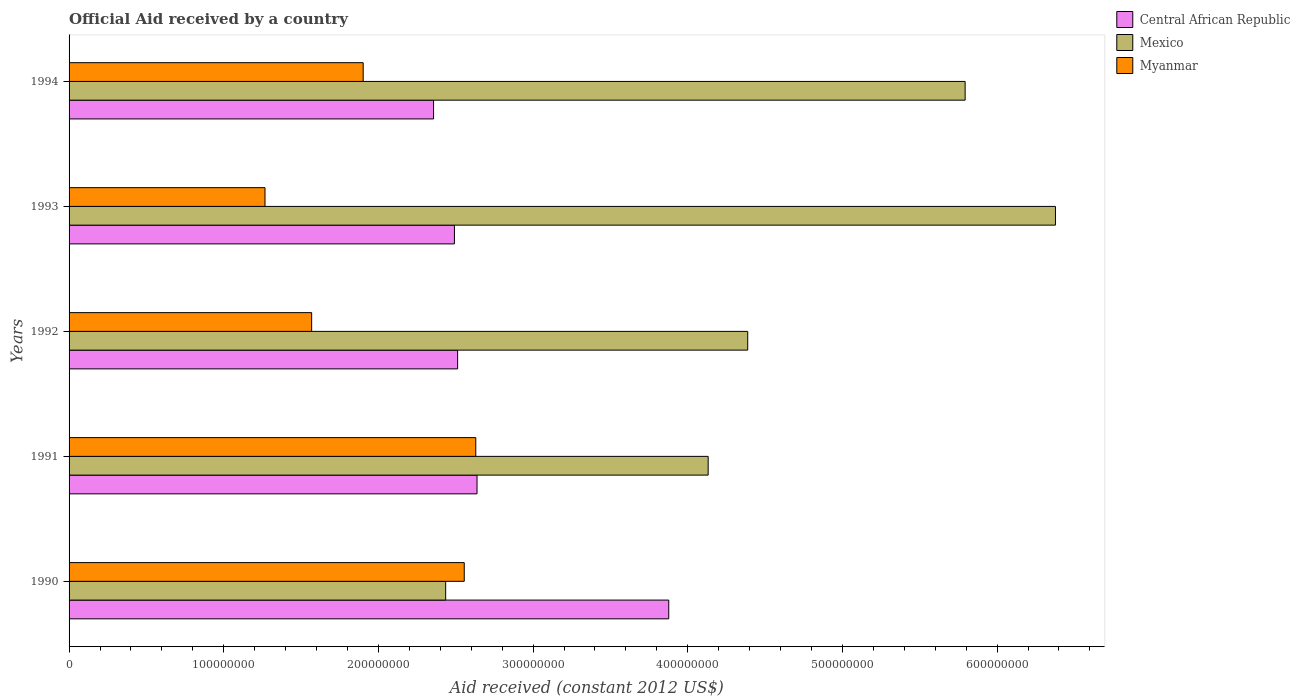How many different coloured bars are there?
Your answer should be compact. 3. Are the number of bars per tick equal to the number of legend labels?
Your answer should be very brief. Yes. Are the number of bars on each tick of the Y-axis equal?
Offer a terse response. Yes. What is the net official aid received in Mexico in 1990?
Ensure brevity in your answer.  2.43e+08. Across all years, what is the maximum net official aid received in Myanmar?
Offer a very short reply. 2.63e+08. Across all years, what is the minimum net official aid received in Mexico?
Ensure brevity in your answer.  2.43e+08. In which year was the net official aid received in Central African Republic maximum?
Provide a short and direct response. 1990. What is the total net official aid received in Central African Republic in the graph?
Make the answer very short. 1.39e+09. What is the difference between the net official aid received in Mexico in 1993 and that in 1994?
Make the answer very short. 5.84e+07. What is the difference between the net official aid received in Myanmar in 1990 and the net official aid received in Central African Republic in 1994?
Your answer should be compact. 1.98e+07. What is the average net official aid received in Mexico per year?
Offer a very short reply. 4.62e+08. In the year 1990, what is the difference between the net official aid received in Central African Republic and net official aid received in Myanmar?
Your answer should be very brief. 1.32e+08. What is the ratio of the net official aid received in Mexico in 1990 to that in 1994?
Give a very brief answer. 0.42. Is the net official aid received in Mexico in 1991 less than that in 1994?
Your answer should be very brief. Yes. What is the difference between the highest and the second highest net official aid received in Myanmar?
Ensure brevity in your answer.  7.46e+06. What is the difference between the highest and the lowest net official aid received in Central African Republic?
Your response must be concise. 1.52e+08. In how many years, is the net official aid received in Mexico greater than the average net official aid received in Mexico taken over all years?
Ensure brevity in your answer.  2. What does the 2nd bar from the top in 1990 represents?
Ensure brevity in your answer.  Mexico. What does the 3rd bar from the bottom in 1994 represents?
Your answer should be compact. Myanmar. Are all the bars in the graph horizontal?
Offer a very short reply. Yes. How many legend labels are there?
Make the answer very short. 3. What is the title of the graph?
Keep it short and to the point. Official Aid received by a country. What is the label or title of the X-axis?
Provide a short and direct response. Aid received (constant 2012 US$). What is the Aid received (constant 2012 US$) in Central African Republic in 1990?
Your answer should be compact. 3.88e+08. What is the Aid received (constant 2012 US$) in Mexico in 1990?
Your response must be concise. 2.43e+08. What is the Aid received (constant 2012 US$) in Myanmar in 1990?
Provide a short and direct response. 2.55e+08. What is the Aid received (constant 2012 US$) of Central African Republic in 1991?
Offer a very short reply. 2.64e+08. What is the Aid received (constant 2012 US$) of Mexico in 1991?
Your answer should be very brief. 4.13e+08. What is the Aid received (constant 2012 US$) of Myanmar in 1991?
Make the answer very short. 2.63e+08. What is the Aid received (constant 2012 US$) in Central African Republic in 1992?
Ensure brevity in your answer.  2.51e+08. What is the Aid received (constant 2012 US$) in Mexico in 1992?
Your answer should be very brief. 4.39e+08. What is the Aid received (constant 2012 US$) in Myanmar in 1992?
Give a very brief answer. 1.57e+08. What is the Aid received (constant 2012 US$) in Central African Republic in 1993?
Your answer should be compact. 2.49e+08. What is the Aid received (constant 2012 US$) of Mexico in 1993?
Your response must be concise. 6.38e+08. What is the Aid received (constant 2012 US$) of Myanmar in 1993?
Your answer should be compact. 1.27e+08. What is the Aid received (constant 2012 US$) of Central African Republic in 1994?
Provide a succinct answer. 2.36e+08. What is the Aid received (constant 2012 US$) in Mexico in 1994?
Offer a terse response. 5.79e+08. What is the Aid received (constant 2012 US$) of Myanmar in 1994?
Provide a short and direct response. 1.90e+08. Across all years, what is the maximum Aid received (constant 2012 US$) of Central African Republic?
Make the answer very short. 3.88e+08. Across all years, what is the maximum Aid received (constant 2012 US$) in Mexico?
Offer a very short reply. 6.38e+08. Across all years, what is the maximum Aid received (constant 2012 US$) of Myanmar?
Ensure brevity in your answer.  2.63e+08. Across all years, what is the minimum Aid received (constant 2012 US$) of Central African Republic?
Provide a short and direct response. 2.36e+08. Across all years, what is the minimum Aid received (constant 2012 US$) of Mexico?
Provide a short and direct response. 2.43e+08. Across all years, what is the minimum Aid received (constant 2012 US$) of Myanmar?
Provide a short and direct response. 1.27e+08. What is the total Aid received (constant 2012 US$) of Central African Republic in the graph?
Give a very brief answer. 1.39e+09. What is the total Aid received (constant 2012 US$) in Mexico in the graph?
Keep it short and to the point. 2.31e+09. What is the total Aid received (constant 2012 US$) of Myanmar in the graph?
Offer a very short reply. 9.92e+08. What is the difference between the Aid received (constant 2012 US$) in Central African Republic in 1990 and that in 1991?
Offer a terse response. 1.24e+08. What is the difference between the Aid received (constant 2012 US$) in Mexico in 1990 and that in 1991?
Your response must be concise. -1.70e+08. What is the difference between the Aid received (constant 2012 US$) in Myanmar in 1990 and that in 1991?
Provide a succinct answer. -7.46e+06. What is the difference between the Aid received (constant 2012 US$) of Central African Republic in 1990 and that in 1992?
Make the answer very short. 1.36e+08. What is the difference between the Aid received (constant 2012 US$) of Mexico in 1990 and that in 1992?
Your answer should be very brief. -1.95e+08. What is the difference between the Aid received (constant 2012 US$) in Myanmar in 1990 and that in 1992?
Provide a succinct answer. 9.86e+07. What is the difference between the Aid received (constant 2012 US$) in Central African Republic in 1990 and that in 1993?
Your response must be concise. 1.39e+08. What is the difference between the Aid received (constant 2012 US$) of Mexico in 1990 and that in 1993?
Give a very brief answer. -3.94e+08. What is the difference between the Aid received (constant 2012 US$) of Myanmar in 1990 and that in 1993?
Your response must be concise. 1.29e+08. What is the difference between the Aid received (constant 2012 US$) in Central African Republic in 1990 and that in 1994?
Offer a terse response. 1.52e+08. What is the difference between the Aid received (constant 2012 US$) of Mexico in 1990 and that in 1994?
Offer a terse response. -3.36e+08. What is the difference between the Aid received (constant 2012 US$) in Myanmar in 1990 and that in 1994?
Provide a short and direct response. 6.54e+07. What is the difference between the Aid received (constant 2012 US$) in Central African Republic in 1991 and that in 1992?
Provide a short and direct response. 1.26e+07. What is the difference between the Aid received (constant 2012 US$) of Mexico in 1991 and that in 1992?
Your answer should be compact. -2.56e+07. What is the difference between the Aid received (constant 2012 US$) of Myanmar in 1991 and that in 1992?
Keep it short and to the point. 1.06e+08. What is the difference between the Aid received (constant 2012 US$) of Central African Republic in 1991 and that in 1993?
Your response must be concise. 1.46e+07. What is the difference between the Aid received (constant 2012 US$) of Mexico in 1991 and that in 1993?
Give a very brief answer. -2.25e+08. What is the difference between the Aid received (constant 2012 US$) of Myanmar in 1991 and that in 1993?
Ensure brevity in your answer.  1.36e+08. What is the difference between the Aid received (constant 2012 US$) of Central African Republic in 1991 and that in 1994?
Make the answer very short. 2.81e+07. What is the difference between the Aid received (constant 2012 US$) in Mexico in 1991 and that in 1994?
Ensure brevity in your answer.  -1.66e+08. What is the difference between the Aid received (constant 2012 US$) in Myanmar in 1991 and that in 1994?
Provide a short and direct response. 7.28e+07. What is the difference between the Aid received (constant 2012 US$) of Central African Republic in 1992 and that in 1993?
Give a very brief answer. 2.06e+06. What is the difference between the Aid received (constant 2012 US$) of Mexico in 1992 and that in 1993?
Offer a terse response. -1.99e+08. What is the difference between the Aid received (constant 2012 US$) of Myanmar in 1992 and that in 1993?
Make the answer very short. 3.02e+07. What is the difference between the Aid received (constant 2012 US$) of Central African Republic in 1992 and that in 1994?
Provide a short and direct response. 1.56e+07. What is the difference between the Aid received (constant 2012 US$) in Mexico in 1992 and that in 1994?
Give a very brief answer. -1.41e+08. What is the difference between the Aid received (constant 2012 US$) in Myanmar in 1992 and that in 1994?
Ensure brevity in your answer.  -3.33e+07. What is the difference between the Aid received (constant 2012 US$) in Central African Republic in 1993 and that in 1994?
Give a very brief answer. 1.35e+07. What is the difference between the Aid received (constant 2012 US$) in Mexico in 1993 and that in 1994?
Your response must be concise. 5.84e+07. What is the difference between the Aid received (constant 2012 US$) in Myanmar in 1993 and that in 1994?
Provide a succinct answer. -6.35e+07. What is the difference between the Aid received (constant 2012 US$) of Central African Republic in 1990 and the Aid received (constant 2012 US$) of Mexico in 1991?
Your response must be concise. -2.55e+07. What is the difference between the Aid received (constant 2012 US$) in Central African Republic in 1990 and the Aid received (constant 2012 US$) in Myanmar in 1991?
Ensure brevity in your answer.  1.25e+08. What is the difference between the Aid received (constant 2012 US$) in Mexico in 1990 and the Aid received (constant 2012 US$) in Myanmar in 1991?
Make the answer very short. -1.95e+07. What is the difference between the Aid received (constant 2012 US$) of Central African Republic in 1990 and the Aid received (constant 2012 US$) of Mexico in 1992?
Offer a very short reply. -5.10e+07. What is the difference between the Aid received (constant 2012 US$) in Central African Republic in 1990 and the Aid received (constant 2012 US$) in Myanmar in 1992?
Ensure brevity in your answer.  2.31e+08. What is the difference between the Aid received (constant 2012 US$) of Mexico in 1990 and the Aid received (constant 2012 US$) of Myanmar in 1992?
Ensure brevity in your answer.  8.66e+07. What is the difference between the Aid received (constant 2012 US$) in Central African Republic in 1990 and the Aid received (constant 2012 US$) in Mexico in 1993?
Offer a terse response. -2.50e+08. What is the difference between the Aid received (constant 2012 US$) of Central African Republic in 1990 and the Aid received (constant 2012 US$) of Myanmar in 1993?
Give a very brief answer. 2.61e+08. What is the difference between the Aid received (constant 2012 US$) of Mexico in 1990 and the Aid received (constant 2012 US$) of Myanmar in 1993?
Your answer should be compact. 1.17e+08. What is the difference between the Aid received (constant 2012 US$) in Central African Republic in 1990 and the Aid received (constant 2012 US$) in Mexico in 1994?
Make the answer very short. -1.92e+08. What is the difference between the Aid received (constant 2012 US$) of Central African Republic in 1990 and the Aid received (constant 2012 US$) of Myanmar in 1994?
Make the answer very short. 1.98e+08. What is the difference between the Aid received (constant 2012 US$) of Mexico in 1990 and the Aid received (constant 2012 US$) of Myanmar in 1994?
Ensure brevity in your answer.  5.33e+07. What is the difference between the Aid received (constant 2012 US$) of Central African Republic in 1991 and the Aid received (constant 2012 US$) of Mexico in 1992?
Your answer should be very brief. -1.75e+08. What is the difference between the Aid received (constant 2012 US$) in Central African Republic in 1991 and the Aid received (constant 2012 US$) in Myanmar in 1992?
Your answer should be very brief. 1.07e+08. What is the difference between the Aid received (constant 2012 US$) of Mexico in 1991 and the Aid received (constant 2012 US$) of Myanmar in 1992?
Provide a short and direct response. 2.56e+08. What is the difference between the Aid received (constant 2012 US$) of Central African Republic in 1991 and the Aid received (constant 2012 US$) of Mexico in 1993?
Keep it short and to the point. -3.74e+08. What is the difference between the Aid received (constant 2012 US$) of Central African Republic in 1991 and the Aid received (constant 2012 US$) of Myanmar in 1993?
Make the answer very short. 1.37e+08. What is the difference between the Aid received (constant 2012 US$) of Mexico in 1991 and the Aid received (constant 2012 US$) of Myanmar in 1993?
Your answer should be compact. 2.87e+08. What is the difference between the Aid received (constant 2012 US$) in Central African Republic in 1991 and the Aid received (constant 2012 US$) in Mexico in 1994?
Provide a short and direct response. -3.16e+08. What is the difference between the Aid received (constant 2012 US$) of Central African Republic in 1991 and the Aid received (constant 2012 US$) of Myanmar in 1994?
Offer a very short reply. 7.36e+07. What is the difference between the Aid received (constant 2012 US$) of Mexico in 1991 and the Aid received (constant 2012 US$) of Myanmar in 1994?
Your answer should be compact. 2.23e+08. What is the difference between the Aid received (constant 2012 US$) in Central African Republic in 1992 and the Aid received (constant 2012 US$) in Mexico in 1993?
Ensure brevity in your answer.  -3.87e+08. What is the difference between the Aid received (constant 2012 US$) of Central African Republic in 1992 and the Aid received (constant 2012 US$) of Myanmar in 1993?
Ensure brevity in your answer.  1.25e+08. What is the difference between the Aid received (constant 2012 US$) of Mexico in 1992 and the Aid received (constant 2012 US$) of Myanmar in 1993?
Offer a very short reply. 3.12e+08. What is the difference between the Aid received (constant 2012 US$) of Central African Republic in 1992 and the Aid received (constant 2012 US$) of Mexico in 1994?
Your answer should be very brief. -3.28e+08. What is the difference between the Aid received (constant 2012 US$) in Central African Republic in 1992 and the Aid received (constant 2012 US$) in Myanmar in 1994?
Keep it short and to the point. 6.11e+07. What is the difference between the Aid received (constant 2012 US$) of Mexico in 1992 and the Aid received (constant 2012 US$) of Myanmar in 1994?
Give a very brief answer. 2.49e+08. What is the difference between the Aid received (constant 2012 US$) in Central African Republic in 1993 and the Aid received (constant 2012 US$) in Mexico in 1994?
Make the answer very short. -3.30e+08. What is the difference between the Aid received (constant 2012 US$) of Central African Republic in 1993 and the Aid received (constant 2012 US$) of Myanmar in 1994?
Offer a terse response. 5.90e+07. What is the difference between the Aid received (constant 2012 US$) in Mexico in 1993 and the Aid received (constant 2012 US$) in Myanmar in 1994?
Offer a terse response. 4.48e+08. What is the average Aid received (constant 2012 US$) of Central African Republic per year?
Your response must be concise. 2.77e+08. What is the average Aid received (constant 2012 US$) in Mexico per year?
Your response must be concise. 4.62e+08. What is the average Aid received (constant 2012 US$) of Myanmar per year?
Make the answer very short. 1.98e+08. In the year 1990, what is the difference between the Aid received (constant 2012 US$) in Central African Republic and Aid received (constant 2012 US$) in Mexico?
Give a very brief answer. 1.44e+08. In the year 1990, what is the difference between the Aid received (constant 2012 US$) in Central African Republic and Aid received (constant 2012 US$) in Myanmar?
Your answer should be compact. 1.32e+08. In the year 1990, what is the difference between the Aid received (constant 2012 US$) in Mexico and Aid received (constant 2012 US$) in Myanmar?
Your answer should be very brief. -1.20e+07. In the year 1991, what is the difference between the Aid received (constant 2012 US$) in Central African Republic and Aid received (constant 2012 US$) in Mexico?
Provide a succinct answer. -1.49e+08. In the year 1991, what is the difference between the Aid received (constant 2012 US$) in Central African Republic and Aid received (constant 2012 US$) in Myanmar?
Make the answer very short. 8.10e+05. In the year 1991, what is the difference between the Aid received (constant 2012 US$) in Mexico and Aid received (constant 2012 US$) in Myanmar?
Provide a succinct answer. 1.50e+08. In the year 1992, what is the difference between the Aid received (constant 2012 US$) of Central African Republic and Aid received (constant 2012 US$) of Mexico?
Give a very brief answer. -1.88e+08. In the year 1992, what is the difference between the Aid received (constant 2012 US$) of Central African Republic and Aid received (constant 2012 US$) of Myanmar?
Offer a terse response. 9.44e+07. In the year 1992, what is the difference between the Aid received (constant 2012 US$) in Mexico and Aid received (constant 2012 US$) in Myanmar?
Offer a terse response. 2.82e+08. In the year 1993, what is the difference between the Aid received (constant 2012 US$) in Central African Republic and Aid received (constant 2012 US$) in Mexico?
Make the answer very short. -3.89e+08. In the year 1993, what is the difference between the Aid received (constant 2012 US$) of Central African Republic and Aid received (constant 2012 US$) of Myanmar?
Ensure brevity in your answer.  1.22e+08. In the year 1993, what is the difference between the Aid received (constant 2012 US$) in Mexico and Aid received (constant 2012 US$) in Myanmar?
Offer a terse response. 5.11e+08. In the year 1994, what is the difference between the Aid received (constant 2012 US$) in Central African Republic and Aid received (constant 2012 US$) in Mexico?
Provide a short and direct response. -3.44e+08. In the year 1994, what is the difference between the Aid received (constant 2012 US$) of Central African Republic and Aid received (constant 2012 US$) of Myanmar?
Make the answer very short. 4.55e+07. In the year 1994, what is the difference between the Aid received (constant 2012 US$) of Mexico and Aid received (constant 2012 US$) of Myanmar?
Provide a short and direct response. 3.89e+08. What is the ratio of the Aid received (constant 2012 US$) of Central African Republic in 1990 to that in 1991?
Ensure brevity in your answer.  1.47. What is the ratio of the Aid received (constant 2012 US$) in Mexico in 1990 to that in 1991?
Offer a terse response. 0.59. What is the ratio of the Aid received (constant 2012 US$) in Myanmar in 1990 to that in 1991?
Provide a short and direct response. 0.97. What is the ratio of the Aid received (constant 2012 US$) in Central African Republic in 1990 to that in 1992?
Offer a terse response. 1.54. What is the ratio of the Aid received (constant 2012 US$) in Mexico in 1990 to that in 1992?
Keep it short and to the point. 0.55. What is the ratio of the Aid received (constant 2012 US$) in Myanmar in 1990 to that in 1992?
Make the answer very short. 1.63. What is the ratio of the Aid received (constant 2012 US$) in Central African Republic in 1990 to that in 1993?
Your answer should be very brief. 1.56. What is the ratio of the Aid received (constant 2012 US$) in Mexico in 1990 to that in 1993?
Your answer should be compact. 0.38. What is the ratio of the Aid received (constant 2012 US$) in Myanmar in 1990 to that in 1993?
Offer a very short reply. 2.02. What is the ratio of the Aid received (constant 2012 US$) in Central African Republic in 1990 to that in 1994?
Ensure brevity in your answer.  1.65. What is the ratio of the Aid received (constant 2012 US$) in Mexico in 1990 to that in 1994?
Your response must be concise. 0.42. What is the ratio of the Aid received (constant 2012 US$) in Myanmar in 1990 to that in 1994?
Give a very brief answer. 1.34. What is the ratio of the Aid received (constant 2012 US$) of Mexico in 1991 to that in 1992?
Keep it short and to the point. 0.94. What is the ratio of the Aid received (constant 2012 US$) in Myanmar in 1991 to that in 1992?
Give a very brief answer. 1.68. What is the ratio of the Aid received (constant 2012 US$) of Central African Republic in 1991 to that in 1993?
Your answer should be compact. 1.06. What is the ratio of the Aid received (constant 2012 US$) of Mexico in 1991 to that in 1993?
Keep it short and to the point. 0.65. What is the ratio of the Aid received (constant 2012 US$) in Myanmar in 1991 to that in 1993?
Give a very brief answer. 2.08. What is the ratio of the Aid received (constant 2012 US$) in Central African Republic in 1991 to that in 1994?
Keep it short and to the point. 1.12. What is the ratio of the Aid received (constant 2012 US$) of Mexico in 1991 to that in 1994?
Ensure brevity in your answer.  0.71. What is the ratio of the Aid received (constant 2012 US$) in Myanmar in 1991 to that in 1994?
Keep it short and to the point. 1.38. What is the ratio of the Aid received (constant 2012 US$) of Central African Republic in 1992 to that in 1993?
Provide a succinct answer. 1.01. What is the ratio of the Aid received (constant 2012 US$) of Mexico in 1992 to that in 1993?
Your response must be concise. 0.69. What is the ratio of the Aid received (constant 2012 US$) of Myanmar in 1992 to that in 1993?
Provide a succinct answer. 1.24. What is the ratio of the Aid received (constant 2012 US$) in Central African Republic in 1992 to that in 1994?
Your answer should be compact. 1.07. What is the ratio of the Aid received (constant 2012 US$) of Mexico in 1992 to that in 1994?
Your answer should be compact. 0.76. What is the ratio of the Aid received (constant 2012 US$) in Myanmar in 1992 to that in 1994?
Offer a terse response. 0.82. What is the ratio of the Aid received (constant 2012 US$) of Central African Republic in 1993 to that in 1994?
Make the answer very short. 1.06. What is the ratio of the Aid received (constant 2012 US$) in Mexico in 1993 to that in 1994?
Provide a short and direct response. 1.1. What is the ratio of the Aid received (constant 2012 US$) of Myanmar in 1993 to that in 1994?
Your answer should be compact. 0.67. What is the difference between the highest and the second highest Aid received (constant 2012 US$) in Central African Republic?
Your answer should be compact. 1.24e+08. What is the difference between the highest and the second highest Aid received (constant 2012 US$) in Mexico?
Give a very brief answer. 5.84e+07. What is the difference between the highest and the second highest Aid received (constant 2012 US$) of Myanmar?
Your answer should be very brief. 7.46e+06. What is the difference between the highest and the lowest Aid received (constant 2012 US$) of Central African Republic?
Keep it short and to the point. 1.52e+08. What is the difference between the highest and the lowest Aid received (constant 2012 US$) of Mexico?
Provide a succinct answer. 3.94e+08. What is the difference between the highest and the lowest Aid received (constant 2012 US$) in Myanmar?
Offer a terse response. 1.36e+08. 